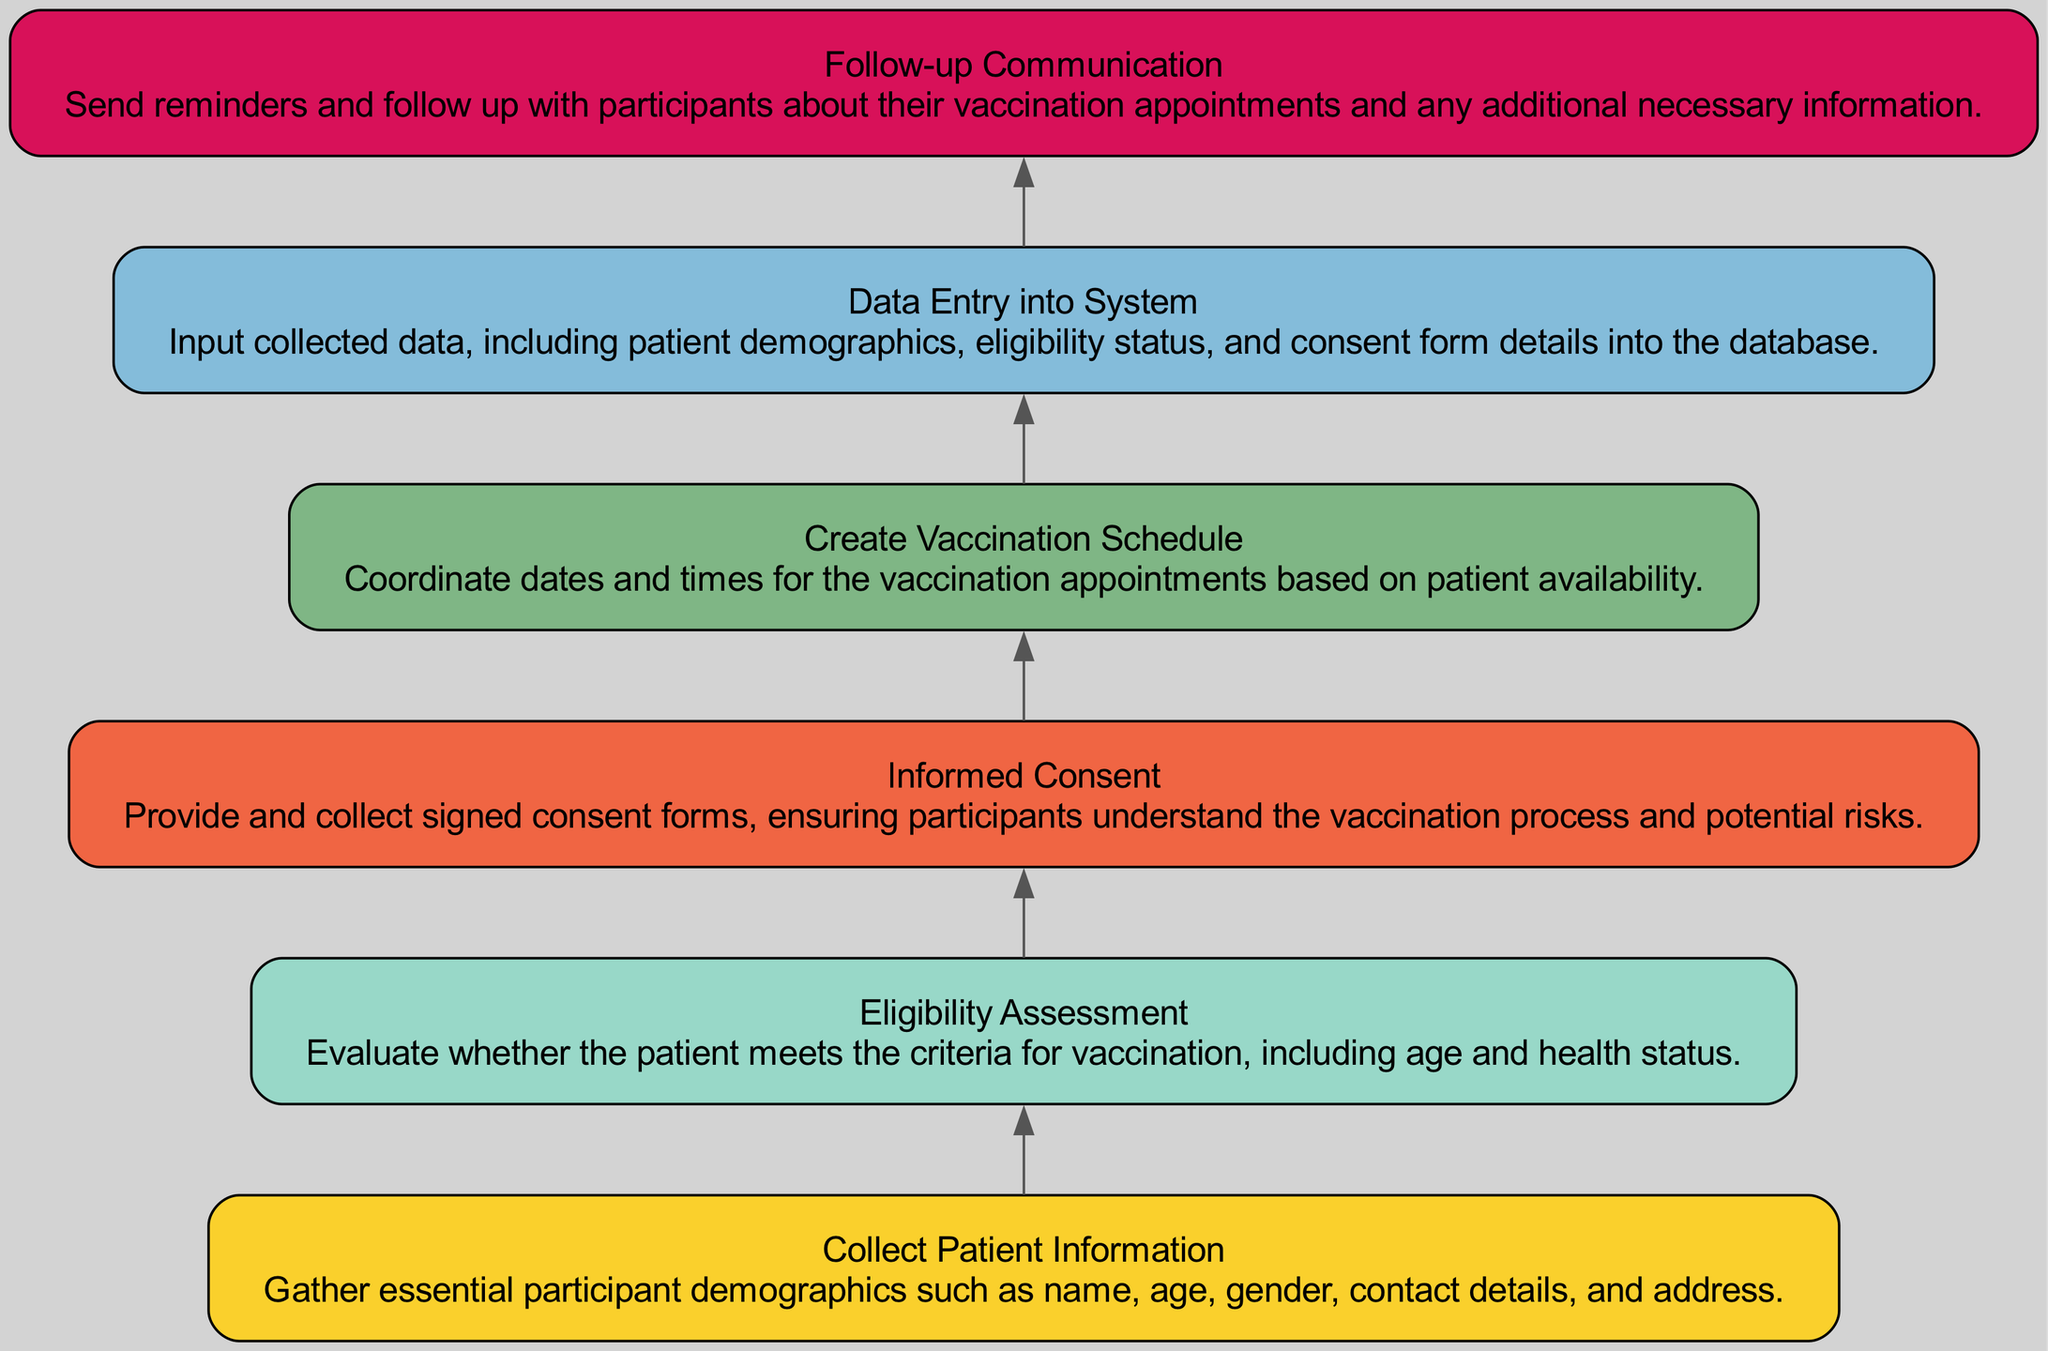What is the first step in the patient enrollment process? The diagram indicates that the first step is "Collect Patient Information." This is evidenced by the fact that it is at the bottom of the flow chart and has no incoming edges from any other node.
Answer: Collect Patient Information How many steps are there in the patient enrollment process? By counting the nodes in the diagram, we find there are six distinct steps. Each of these represents a unique operation in the overall process from data collection to communication.
Answer: Six Which step follows "Informed Consent"? The flow chart shows that "Create Vaccination Schedule" directly follows "Informed Consent," as there is an edge pointing from "Informed Consent" to "Create Vaccination Schedule." This denotes the flow of the process.
Answer: Create Vaccination Schedule What color represents the data entry step? The node labeled "Data Entry into System" has a color that is a shade of blue, specifically identified as #84BCDA in the diagram coding. This coloring is unique to the data entry process.
Answer: Blue What are the two steps involved before data entry into the system? The steps that precede "Data Entry into System" are "Eligibility Assessment" and "Informed Consent," as indicated by the directional edges from these nodes to the data entry node.
Answer: Eligibility Assessment and Informed Consent Explain the flow from collecting patient information to follow-up communication. The process begins with "Collect Patient Information," which leads to "Eligibility Assessment" to check if a patient qualifies. Next, "Informed Consent" ensures participation understanding, followed by scheduling the vaccination. After these steps, "Data Entry into System" is done to log all relevant information. Finally, the last step is "Follow-up Communication" to remind participants, completing the entire process.
Answer: Collect Patient Information to Follow-up Communication What type of sign-off is required before vaccination scheduling? The step "Informed Consent" indicates that participants must provide signed consent forms. This is essential before scheduling as it assures the understanding of the vaccination process and potential risks.
Answer: Signed consent forms 